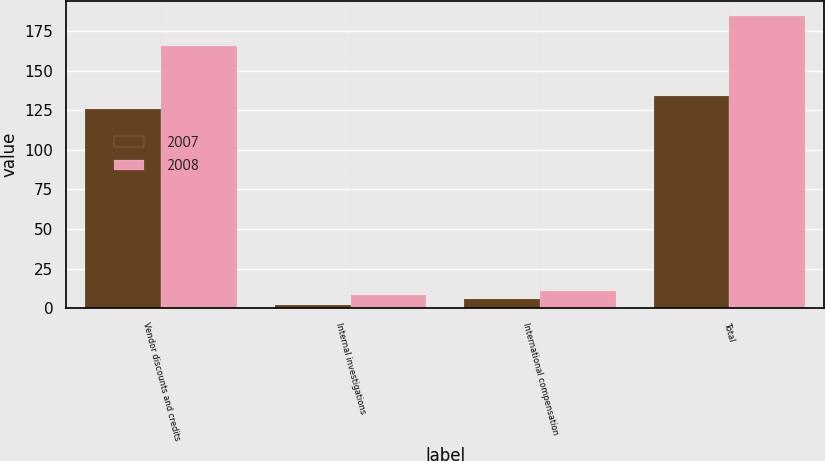<chart> <loc_0><loc_0><loc_500><loc_500><stacked_bar_chart><ecel><fcel>Vendor discounts and credits<fcel>Internal investigations<fcel>International compensation<fcel>Total<nl><fcel>2007<fcel>126<fcel>2.2<fcel>5.8<fcel>134<nl><fcel>2008<fcel>165.5<fcel>8.2<fcel>10.9<fcel>184.6<nl></chart> 